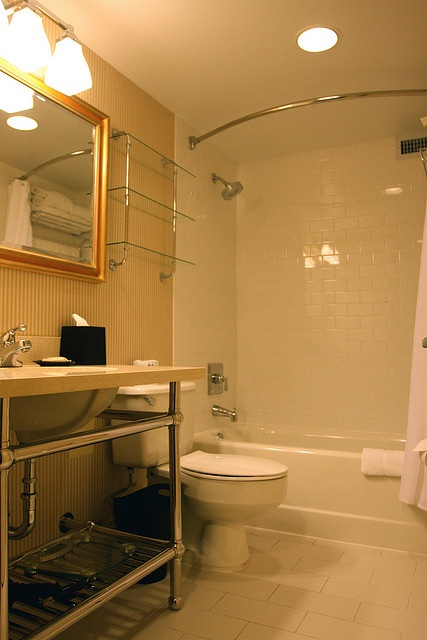Describe the objects in this image and their specific colors. I can see toilet in white, olive, tan, and black tones, sink in white, maroon, olive, and black tones, and sink in white, tan, and olive tones in this image. 